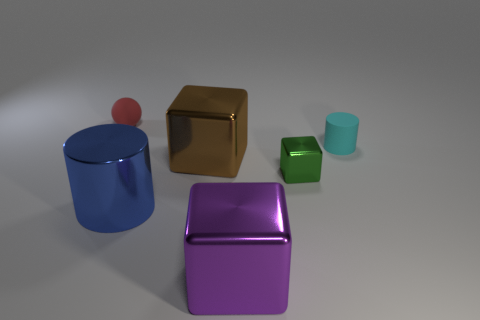Add 3 tiny green metal blocks. How many objects exist? 9 Subtract all balls. How many objects are left? 5 Subtract 1 red spheres. How many objects are left? 5 Subtract all small red rubber objects. Subtract all red rubber things. How many objects are left? 4 Add 1 red matte spheres. How many red matte spheres are left? 2 Add 5 tiny cyan cylinders. How many tiny cyan cylinders exist? 6 